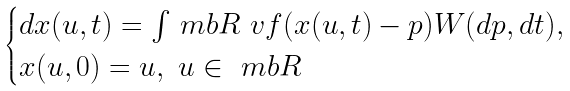Convert formula to latex. <formula><loc_0><loc_0><loc_500><loc_500>\begin{cases} d x ( u , t ) = \int _ { \ } m b R \ v f ( x ( u , t ) - p ) W ( d p , d t ) , \\ x ( u , 0 ) = u , \ u \in \ m b R \end{cases}</formula> 